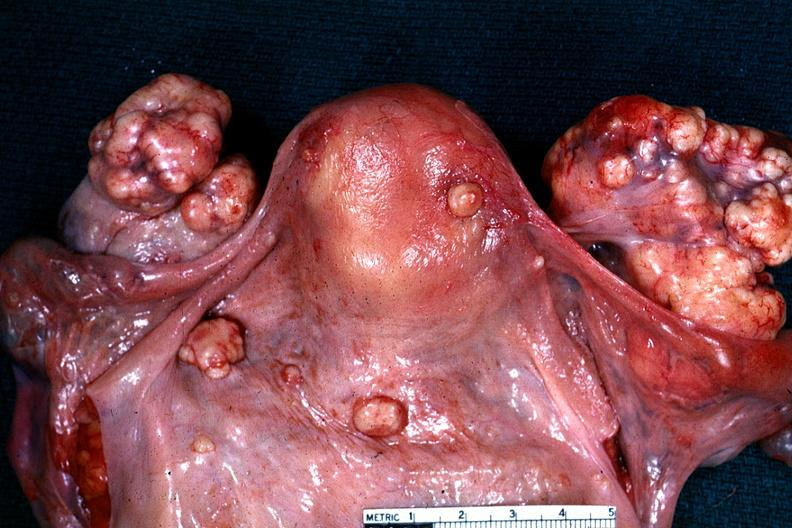s metastatic carcinoma present?
Answer the question using a single word or phrase. Yes 